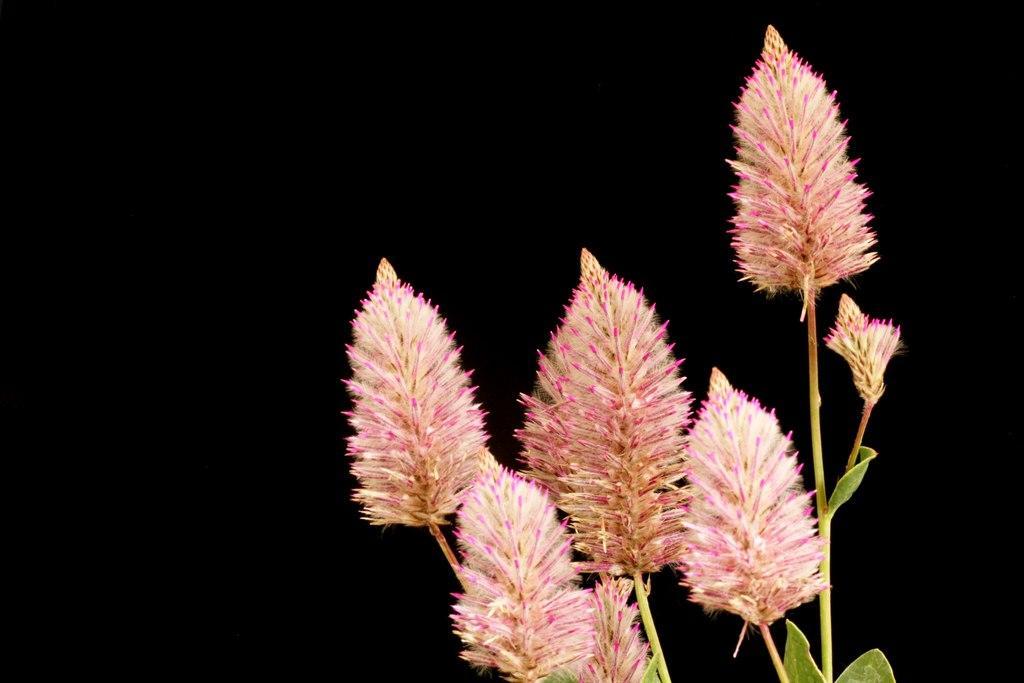In one or two sentences, can you explain what this image depicts? In this image I can see the flowers to the plants. These flowers are in pink and cream color. I can see the black background. 